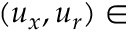<formula> <loc_0><loc_0><loc_500><loc_500>( u _ { x } , u _ { r } ) \in</formula> 